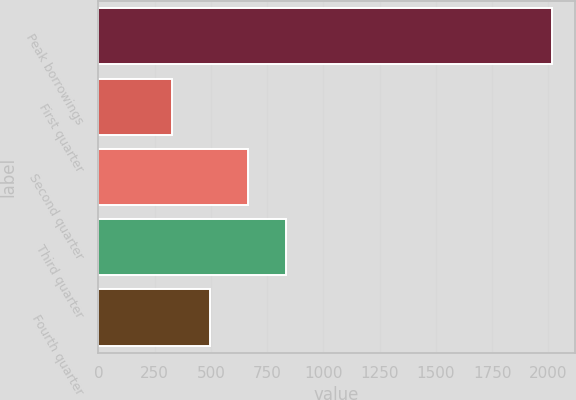Convert chart. <chart><loc_0><loc_0><loc_500><loc_500><bar_chart><fcel>Peak borrowings<fcel>First quarter<fcel>Second quarter<fcel>Third quarter<fcel>Fourth quarter<nl><fcel>2017<fcel>325<fcel>663.4<fcel>832.6<fcel>494.2<nl></chart> 